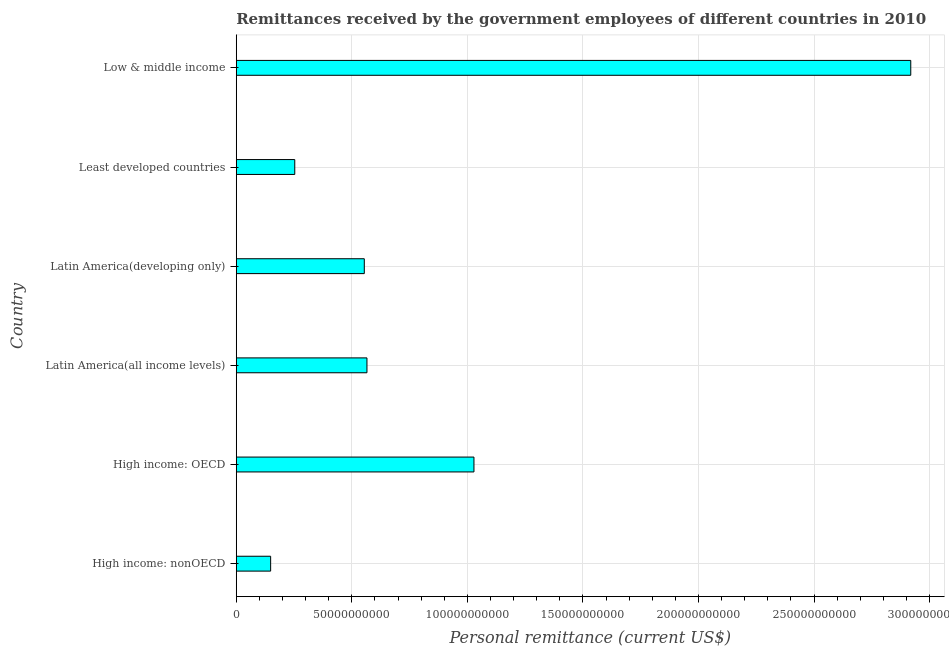Does the graph contain any zero values?
Offer a very short reply. No. What is the title of the graph?
Ensure brevity in your answer.  Remittances received by the government employees of different countries in 2010. What is the label or title of the X-axis?
Ensure brevity in your answer.  Personal remittance (current US$). What is the label or title of the Y-axis?
Provide a short and direct response. Country. What is the personal remittances in High income: nonOECD?
Give a very brief answer. 1.49e+1. Across all countries, what is the maximum personal remittances?
Offer a very short reply. 2.92e+11. Across all countries, what is the minimum personal remittances?
Your answer should be very brief. 1.49e+1. In which country was the personal remittances minimum?
Your answer should be compact. High income: nonOECD. What is the sum of the personal remittances?
Provide a succinct answer. 5.47e+11. What is the difference between the personal remittances in High income: nonOECD and Latin America(all income levels)?
Your response must be concise. -4.17e+1. What is the average personal remittances per country?
Offer a very short reply. 9.11e+1. What is the median personal remittances?
Offer a terse response. 5.60e+1. What is the ratio of the personal remittances in High income: OECD to that in High income: nonOECD?
Offer a very short reply. 6.91. What is the difference between the highest and the second highest personal remittances?
Offer a very short reply. 1.89e+11. Is the sum of the personal remittances in Latin America(all income levels) and Latin America(developing only) greater than the maximum personal remittances across all countries?
Offer a terse response. No. What is the difference between the highest and the lowest personal remittances?
Ensure brevity in your answer.  2.77e+11. In how many countries, is the personal remittances greater than the average personal remittances taken over all countries?
Your answer should be compact. 2. How many bars are there?
Provide a short and direct response. 6. Are all the bars in the graph horizontal?
Ensure brevity in your answer.  Yes. How many countries are there in the graph?
Provide a short and direct response. 6. What is the Personal remittance (current US$) in High income: nonOECD?
Keep it short and to the point. 1.49e+1. What is the Personal remittance (current US$) in High income: OECD?
Offer a terse response. 1.03e+11. What is the Personal remittance (current US$) in Latin America(all income levels)?
Offer a terse response. 5.66e+1. What is the Personal remittance (current US$) in Latin America(developing only)?
Make the answer very short. 5.54e+1. What is the Personal remittance (current US$) in Least developed countries?
Ensure brevity in your answer.  2.53e+1. What is the Personal remittance (current US$) of Low & middle income?
Make the answer very short. 2.92e+11. What is the difference between the Personal remittance (current US$) in High income: nonOECD and High income: OECD?
Offer a very short reply. -8.80e+1. What is the difference between the Personal remittance (current US$) in High income: nonOECD and Latin America(all income levels)?
Keep it short and to the point. -4.17e+1. What is the difference between the Personal remittance (current US$) in High income: nonOECD and Latin America(developing only)?
Your response must be concise. -4.05e+1. What is the difference between the Personal remittance (current US$) in High income: nonOECD and Least developed countries?
Keep it short and to the point. -1.04e+1. What is the difference between the Personal remittance (current US$) in High income: nonOECD and Low & middle income?
Provide a succinct answer. -2.77e+11. What is the difference between the Personal remittance (current US$) in High income: OECD and Latin America(all income levels)?
Your answer should be compact. 4.63e+1. What is the difference between the Personal remittance (current US$) in High income: OECD and Latin America(developing only)?
Ensure brevity in your answer.  4.75e+1. What is the difference between the Personal remittance (current US$) in High income: OECD and Least developed countries?
Provide a short and direct response. 7.75e+1. What is the difference between the Personal remittance (current US$) in High income: OECD and Low & middle income?
Offer a terse response. -1.89e+11. What is the difference between the Personal remittance (current US$) in Latin America(all income levels) and Latin America(developing only)?
Make the answer very short. 1.15e+09. What is the difference between the Personal remittance (current US$) in Latin America(all income levels) and Least developed countries?
Make the answer very short. 3.12e+1. What is the difference between the Personal remittance (current US$) in Latin America(all income levels) and Low & middle income?
Give a very brief answer. -2.35e+11. What is the difference between the Personal remittance (current US$) in Latin America(developing only) and Least developed countries?
Make the answer very short. 3.01e+1. What is the difference between the Personal remittance (current US$) in Latin America(developing only) and Low & middle income?
Your answer should be compact. -2.36e+11. What is the difference between the Personal remittance (current US$) in Least developed countries and Low & middle income?
Offer a terse response. -2.67e+11. What is the ratio of the Personal remittance (current US$) in High income: nonOECD to that in High income: OECD?
Keep it short and to the point. 0.14. What is the ratio of the Personal remittance (current US$) in High income: nonOECD to that in Latin America(all income levels)?
Give a very brief answer. 0.26. What is the ratio of the Personal remittance (current US$) in High income: nonOECD to that in Latin America(developing only)?
Provide a short and direct response. 0.27. What is the ratio of the Personal remittance (current US$) in High income: nonOECD to that in Least developed countries?
Make the answer very short. 0.59. What is the ratio of the Personal remittance (current US$) in High income: nonOECD to that in Low & middle income?
Keep it short and to the point. 0.05. What is the ratio of the Personal remittance (current US$) in High income: OECD to that in Latin America(all income levels)?
Offer a very short reply. 1.82. What is the ratio of the Personal remittance (current US$) in High income: OECD to that in Latin America(developing only)?
Keep it short and to the point. 1.86. What is the ratio of the Personal remittance (current US$) in High income: OECD to that in Least developed countries?
Your answer should be very brief. 4.06. What is the ratio of the Personal remittance (current US$) in High income: OECD to that in Low & middle income?
Keep it short and to the point. 0.35. What is the ratio of the Personal remittance (current US$) in Latin America(all income levels) to that in Least developed countries?
Your answer should be compact. 2.23. What is the ratio of the Personal remittance (current US$) in Latin America(all income levels) to that in Low & middle income?
Provide a short and direct response. 0.19. What is the ratio of the Personal remittance (current US$) in Latin America(developing only) to that in Least developed countries?
Provide a short and direct response. 2.19. What is the ratio of the Personal remittance (current US$) in Latin America(developing only) to that in Low & middle income?
Your answer should be compact. 0.19. What is the ratio of the Personal remittance (current US$) in Least developed countries to that in Low & middle income?
Your answer should be compact. 0.09. 